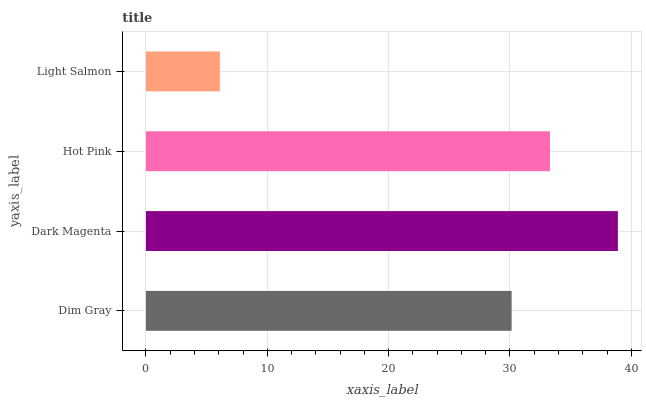Is Light Salmon the minimum?
Answer yes or no. Yes. Is Dark Magenta the maximum?
Answer yes or no. Yes. Is Hot Pink the minimum?
Answer yes or no. No. Is Hot Pink the maximum?
Answer yes or no. No. Is Dark Magenta greater than Hot Pink?
Answer yes or no. Yes. Is Hot Pink less than Dark Magenta?
Answer yes or no. Yes. Is Hot Pink greater than Dark Magenta?
Answer yes or no. No. Is Dark Magenta less than Hot Pink?
Answer yes or no. No. Is Hot Pink the high median?
Answer yes or no. Yes. Is Dim Gray the low median?
Answer yes or no. Yes. Is Dim Gray the high median?
Answer yes or no. No. Is Light Salmon the low median?
Answer yes or no. No. 